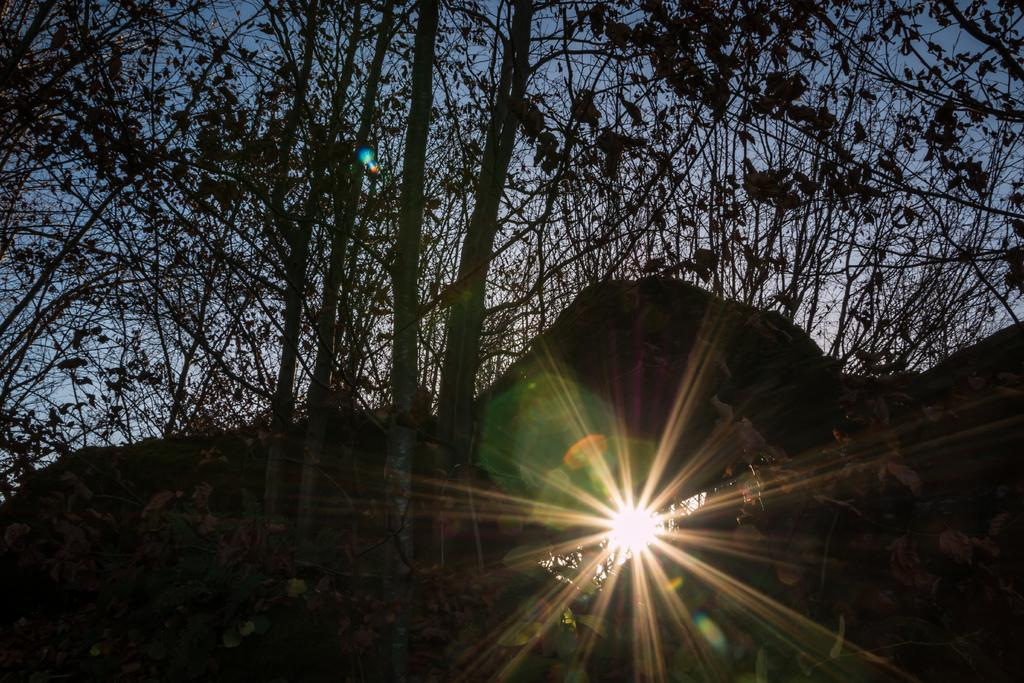What type of natural event is occurring in the image? The image depicts a sunset. What can be seen in the background of the image? There are many trees in the background of the image. How many feet are visible in the image? There are no feet visible in the image; it depicts a sunset with trees in the background. 